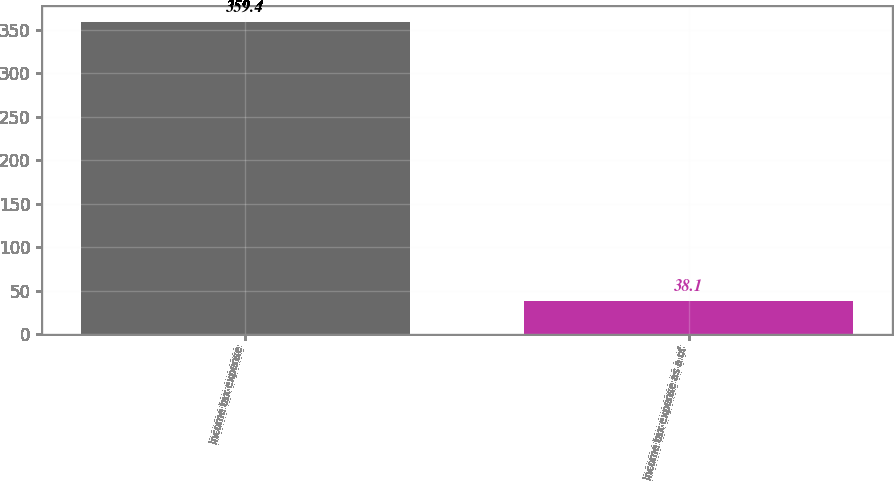<chart> <loc_0><loc_0><loc_500><loc_500><bar_chart><fcel>Income tax expense<fcel>Income tax expense as a of<nl><fcel>359.4<fcel>38.1<nl></chart> 